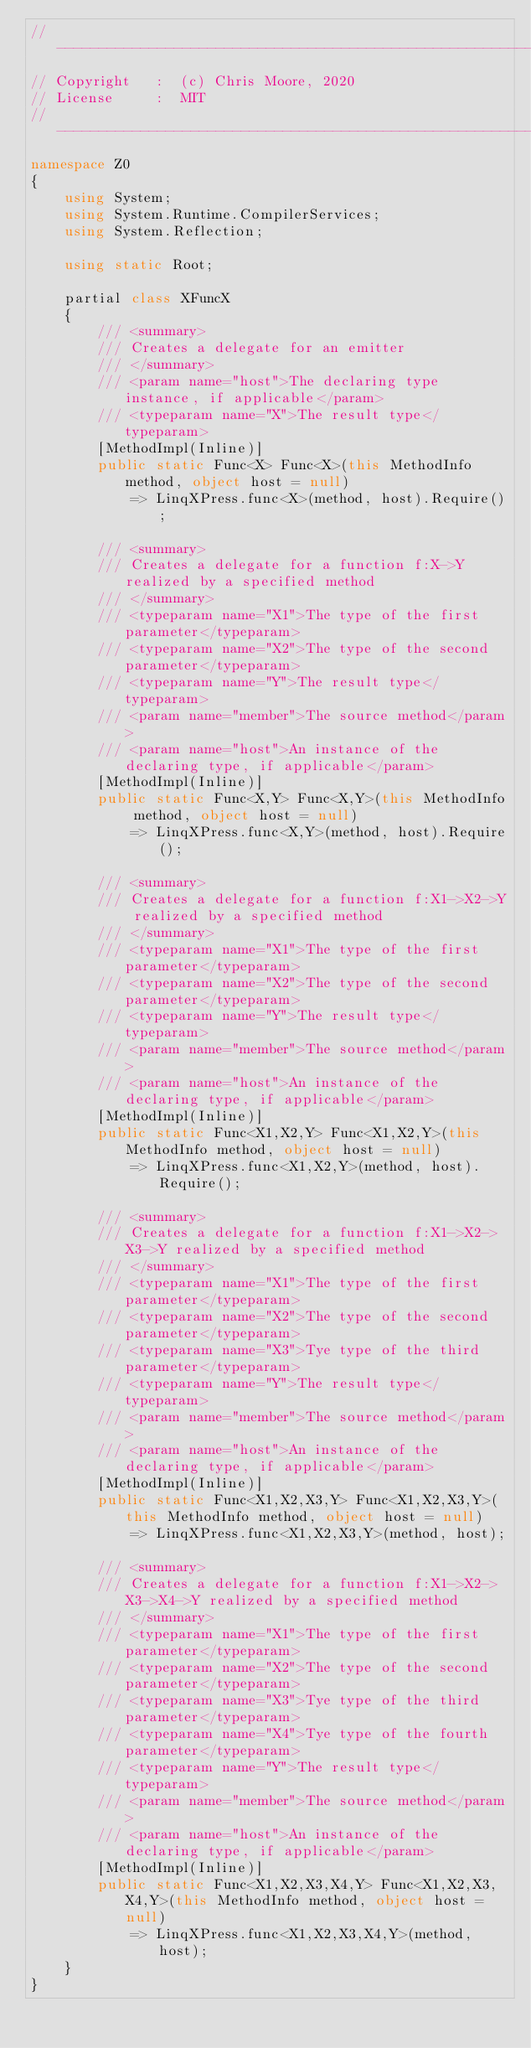Convert code to text. <code><loc_0><loc_0><loc_500><loc_500><_C#_>//-----------------------------------------------------------------------------
// Copyright   :  (c) Chris Moore, 2020
// License     :  MIT
//-----------------------------------------------------------------------------
namespace Z0
{
    using System;
    using System.Runtime.CompilerServices;
    using System.Reflection;

    using static Root;

    partial class XFuncX
    {
        /// <summary>
        /// Creates a delegate for an emitter
        /// </summary>
        /// <param name="host">The declaring type instance, if applicable</param>
        /// <typeparam name="X">The result type</typeparam>
        [MethodImpl(Inline)]
        public static Func<X> Func<X>(this MethodInfo method, object host = null)
            => LinqXPress.func<X>(method, host).Require();

        /// <summary>
        /// Creates a delegate for a function f:X->Y realized by a specified method
        /// </summary>
        /// <typeparam name="X1">The type of the first parameter</typeparam>
        /// <typeparam name="X2">The type of the second parameter</typeparam>
        /// <typeparam name="Y">The result type</typeparam>
        /// <param name="member">The source method</param>
        /// <param name="host">An instance of the declaring type, if applicable</param>
        [MethodImpl(Inline)]
        public static Func<X,Y> Func<X,Y>(this MethodInfo method, object host = null)
            => LinqXPress.func<X,Y>(method, host).Require();

        /// <summary>
        /// Creates a delegate for a function f:X1->X2->Y realized by a specified method
        /// </summary>
        /// <typeparam name="X1">The type of the first parameter</typeparam>
        /// <typeparam name="X2">The type of the second parameter</typeparam>
        /// <typeparam name="Y">The result type</typeparam>
        /// <param name="member">The source method</param>
        /// <param name="host">An instance of the declaring type, if applicable</param>
        [MethodImpl(Inline)]
        public static Func<X1,X2,Y> Func<X1,X2,Y>(this MethodInfo method, object host = null)
            => LinqXPress.func<X1,X2,Y>(method, host).Require();

        /// <summary>
        /// Creates a delegate for a function f:X1->X2->X3->Y realized by a specified method
        /// </summary>
        /// <typeparam name="X1">The type of the first parameter</typeparam>
        /// <typeparam name="X2">The type of the second parameter</typeparam>
        /// <typeparam name="X3">Tye type of the third parameter</typeparam>
        /// <typeparam name="Y">The result type</typeparam>
        /// <param name="member">The source method</param>
        /// <param name="host">An instance of the declaring type, if applicable</param>
        [MethodImpl(Inline)]
        public static Func<X1,X2,X3,Y> Func<X1,X2,X3,Y>(this MethodInfo method, object host = null)
            => LinqXPress.func<X1,X2,X3,Y>(method, host);

        /// <summary>
        /// Creates a delegate for a function f:X1->X2->X3->X4->Y realized by a specified method
        /// </summary>
        /// <typeparam name="X1">The type of the first parameter</typeparam>
        /// <typeparam name="X2">The type of the second parameter</typeparam>
        /// <typeparam name="X3">Tye type of the third parameter</typeparam>
        /// <typeparam name="X4">Tye type of the fourth parameter</typeparam>
        /// <typeparam name="Y">The result type</typeparam>
        /// <param name="member">The source method</param>
        /// <param name="host">An instance of the declaring type, if applicable</param>
        [MethodImpl(Inline)]
        public static Func<X1,X2,X3,X4,Y> Func<X1,X2,X3,X4,Y>(this MethodInfo method, object host = null)
            => LinqXPress.func<X1,X2,X3,X4,Y>(method, host);
    }
}</code> 